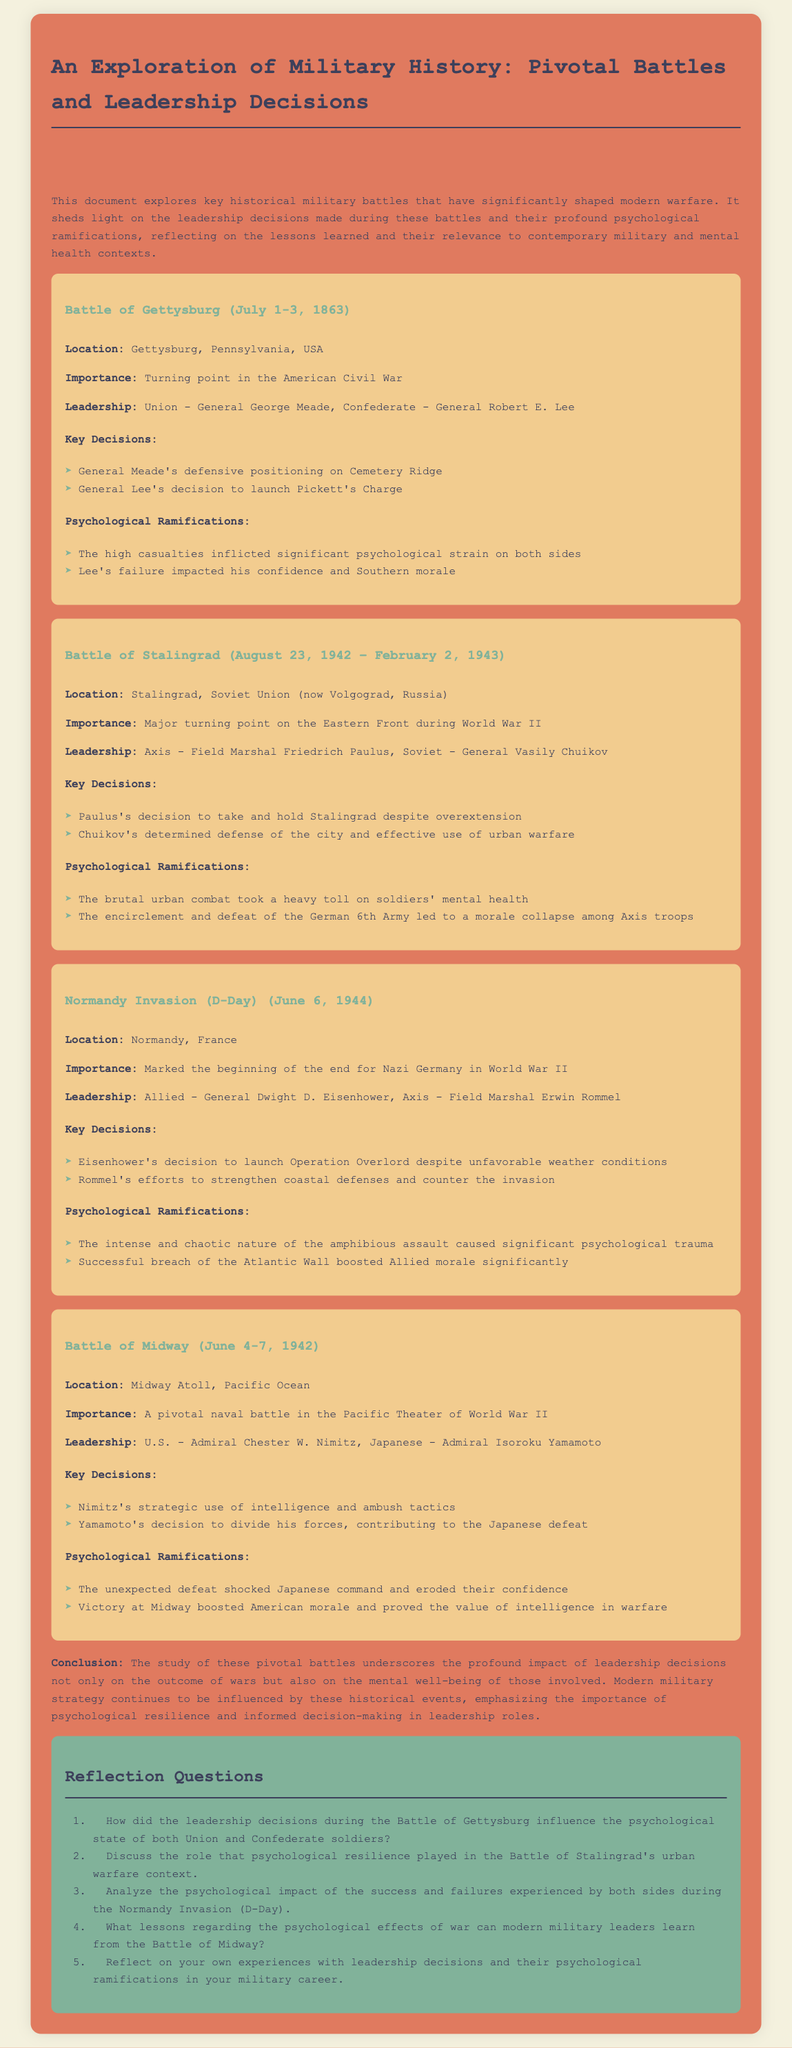What was the location of the Battle of Gettysburg? The battle took place in Gettysburg, Pennsylvania, USA.
Answer: Gettysburg, Pennsylvania, USA Who were the leaders during the Battle of Stalingrad? The leaders were Field Marshal Friedrich Paulus for the Axis and General Vasily Chuikov for the Soviet Union.
Answer: Field Marshal Friedrich Paulus, General Vasily Chuikov What key decision did General Meade make at Gettysburg? General Meade's key decision was to position his forces defensively on Cemetery Ridge.
Answer: Defensive positioning on Cemetery Ridge What was a significant psychological impact of the Normandy Invasion? The successful breach of the Atlantic Wall significantly boosted Allied morale.
Answer: Boosted Allied morale How long did the Battle of Midway last? The Battle of Midway lasted from June 4 to June 7, 1942.
Answer: Four days What was the importance of the Battle of Stalingrad? The battle was a major turning point on the Eastern Front during World War II.
Answer: Major turning point on the Eastern Front What were the psychological ramifications of Lee's failure at Gettysburg? Lee's failure impacted his confidence and Southern morale.
Answer: Impacted his confidence and Southern morale What operation was launched on D-Day? The operation launched was Operation Overlord.
Answer: Operation Overlord 